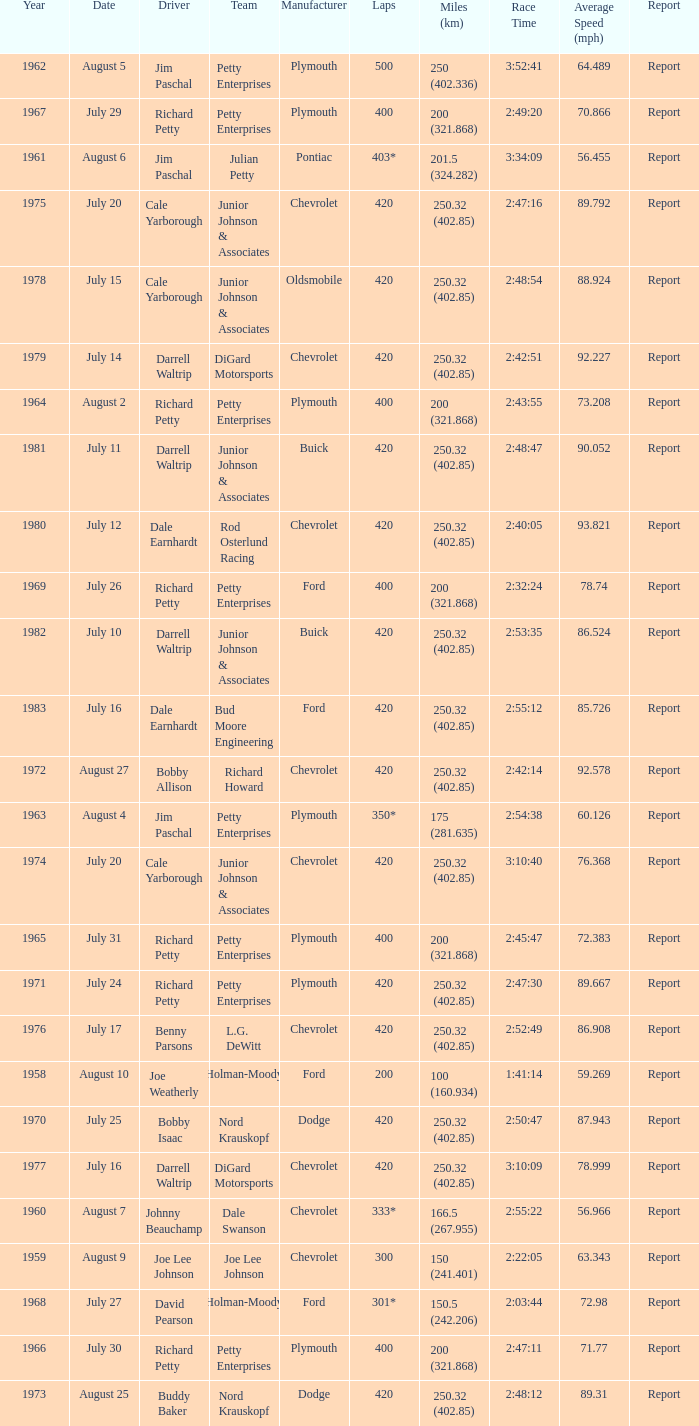How many miles were driven in the race where the winner finished in 2:47:11? 200 (321.868). Would you mind parsing the complete table? {'header': ['Year', 'Date', 'Driver', 'Team', 'Manufacturer', 'Laps', 'Miles (km)', 'Race Time', 'Average Speed (mph)', 'Report'], 'rows': [['1962', 'August 5', 'Jim Paschal', 'Petty Enterprises', 'Plymouth', '500', '250 (402.336)', '3:52:41', '64.489', 'Report'], ['1967', 'July 29', 'Richard Petty', 'Petty Enterprises', 'Plymouth', '400', '200 (321.868)', '2:49:20', '70.866', 'Report'], ['1961', 'August 6', 'Jim Paschal', 'Julian Petty', 'Pontiac', '403*', '201.5 (324.282)', '3:34:09', '56.455', 'Report'], ['1975', 'July 20', 'Cale Yarborough', 'Junior Johnson & Associates', 'Chevrolet', '420', '250.32 (402.85)', '2:47:16', '89.792', 'Report'], ['1978', 'July 15', 'Cale Yarborough', 'Junior Johnson & Associates', 'Oldsmobile', '420', '250.32 (402.85)', '2:48:54', '88.924', 'Report'], ['1979', 'July 14', 'Darrell Waltrip', 'DiGard Motorsports', 'Chevrolet', '420', '250.32 (402.85)', '2:42:51', '92.227', 'Report'], ['1964', 'August 2', 'Richard Petty', 'Petty Enterprises', 'Plymouth', '400', '200 (321.868)', '2:43:55', '73.208', 'Report'], ['1981', 'July 11', 'Darrell Waltrip', 'Junior Johnson & Associates', 'Buick', '420', '250.32 (402.85)', '2:48:47', '90.052', 'Report'], ['1980', 'July 12', 'Dale Earnhardt', 'Rod Osterlund Racing', 'Chevrolet', '420', '250.32 (402.85)', '2:40:05', '93.821', 'Report'], ['1969', 'July 26', 'Richard Petty', 'Petty Enterprises', 'Ford', '400', '200 (321.868)', '2:32:24', '78.74', 'Report'], ['1982', 'July 10', 'Darrell Waltrip', 'Junior Johnson & Associates', 'Buick', '420', '250.32 (402.85)', '2:53:35', '86.524', 'Report'], ['1983', 'July 16', 'Dale Earnhardt', 'Bud Moore Engineering', 'Ford', '420', '250.32 (402.85)', '2:55:12', '85.726', 'Report'], ['1972', 'August 27', 'Bobby Allison', 'Richard Howard', 'Chevrolet', '420', '250.32 (402.85)', '2:42:14', '92.578', 'Report'], ['1963', 'August 4', 'Jim Paschal', 'Petty Enterprises', 'Plymouth', '350*', '175 (281.635)', '2:54:38', '60.126', 'Report'], ['1974', 'July 20', 'Cale Yarborough', 'Junior Johnson & Associates', 'Chevrolet', '420', '250.32 (402.85)', '3:10:40', '76.368', 'Report'], ['1965', 'July 31', 'Richard Petty', 'Petty Enterprises', 'Plymouth', '400', '200 (321.868)', '2:45:47', '72.383', 'Report'], ['1971', 'July 24', 'Richard Petty', 'Petty Enterprises', 'Plymouth', '420', '250.32 (402.85)', '2:47:30', '89.667', 'Report'], ['1976', 'July 17', 'Benny Parsons', 'L.G. DeWitt', 'Chevrolet', '420', '250.32 (402.85)', '2:52:49', '86.908', 'Report'], ['1958', 'August 10', 'Joe Weatherly', 'Holman-Moody', 'Ford', '200', '100 (160.934)', '1:41:14', '59.269', 'Report'], ['1970', 'July 25', 'Bobby Isaac', 'Nord Krauskopf', 'Dodge', '420', '250.32 (402.85)', '2:50:47', '87.943', 'Report'], ['1977', 'July 16', 'Darrell Waltrip', 'DiGard Motorsports', 'Chevrolet', '420', '250.32 (402.85)', '3:10:09', '78.999', 'Report'], ['1960', 'August 7', 'Johnny Beauchamp', 'Dale Swanson', 'Chevrolet', '333*', '166.5 (267.955)', '2:55:22', '56.966', 'Report'], ['1959', 'August 9', 'Joe Lee Johnson', 'Joe Lee Johnson', 'Chevrolet', '300', '150 (241.401)', '2:22:05', '63.343', 'Report'], ['1968', 'July 27', 'David Pearson', 'Holman-Moody', 'Ford', '301*', '150.5 (242.206)', '2:03:44', '72.98', 'Report'], ['1966', 'July 30', 'Richard Petty', 'Petty Enterprises', 'Plymouth', '400', '200 (321.868)', '2:47:11', '71.77', 'Report'], ['1973', 'August 25', 'Buddy Baker', 'Nord Krauskopf', 'Dodge', '420', '250.32 (402.85)', '2:48:12', '89.31', 'Report']]} 